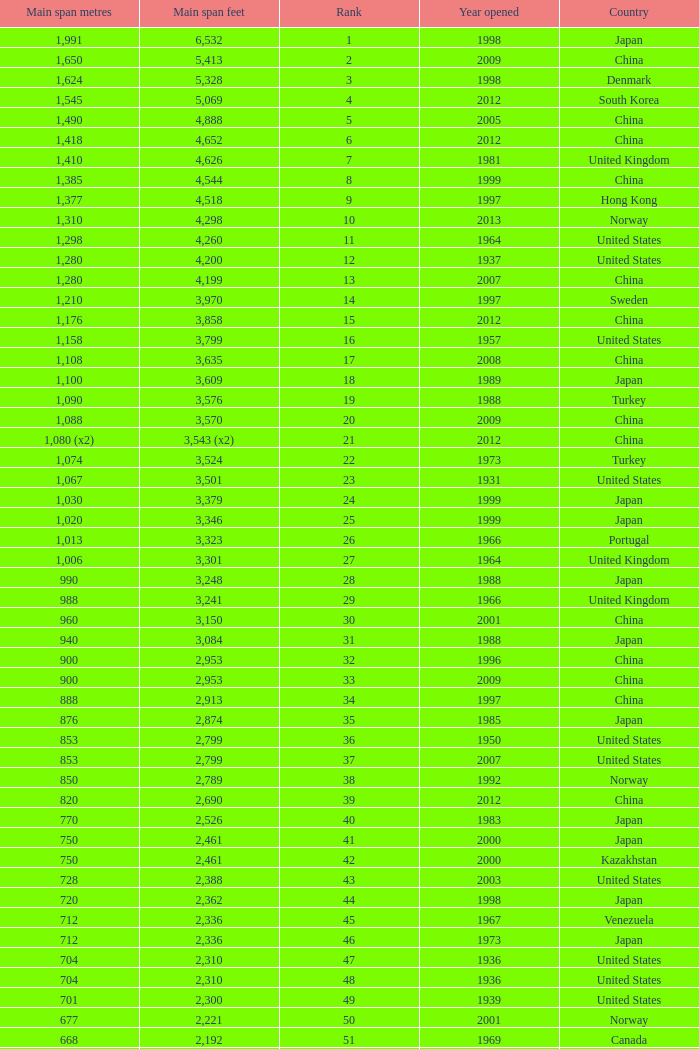What is the main span in feet from a year of 2009 or more recent with a rank less than 94 and 1,310 main span metres? 4298.0. 